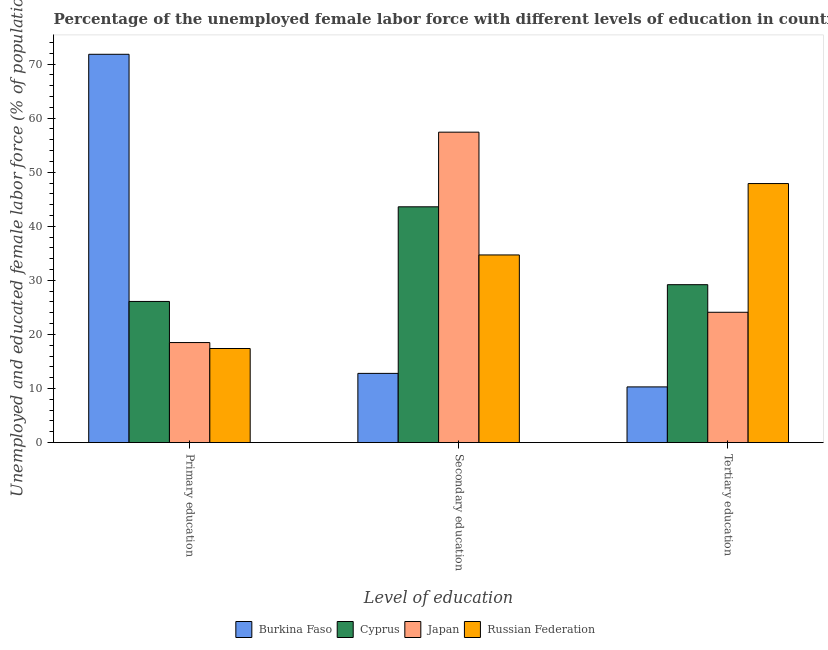What is the label of the 3rd group of bars from the left?
Provide a succinct answer. Tertiary education. What is the percentage of female labor force who received tertiary education in Japan?
Offer a very short reply. 24.1. Across all countries, what is the maximum percentage of female labor force who received secondary education?
Provide a succinct answer. 57.4. Across all countries, what is the minimum percentage of female labor force who received secondary education?
Your answer should be very brief. 12.8. In which country was the percentage of female labor force who received secondary education maximum?
Provide a short and direct response. Japan. In which country was the percentage of female labor force who received primary education minimum?
Give a very brief answer. Russian Federation. What is the total percentage of female labor force who received secondary education in the graph?
Offer a very short reply. 148.5. What is the difference between the percentage of female labor force who received primary education in Japan and that in Cyprus?
Your answer should be compact. -7.6. What is the difference between the percentage of female labor force who received secondary education in Japan and the percentage of female labor force who received primary education in Burkina Faso?
Offer a very short reply. -14.4. What is the average percentage of female labor force who received secondary education per country?
Your response must be concise. 37.13. What is the difference between the percentage of female labor force who received primary education and percentage of female labor force who received tertiary education in Burkina Faso?
Offer a very short reply. 61.5. In how many countries, is the percentage of female labor force who received tertiary education greater than 26 %?
Keep it short and to the point. 2. What is the ratio of the percentage of female labor force who received tertiary education in Burkina Faso to that in Japan?
Offer a terse response. 0.43. Is the percentage of female labor force who received tertiary education in Russian Federation less than that in Cyprus?
Your response must be concise. No. What is the difference between the highest and the second highest percentage of female labor force who received tertiary education?
Make the answer very short. 18.7. What is the difference between the highest and the lowest percentage of female labor force who received tertiary education?
Ensure brevity in your answer.  37.6. What does the 2nd bar from the right in Secondary education represents?
Your response must be concise. Japan. How many bars are there?
Give a very brief answer. 12. Are all the bars in the graph horizontal?
Provide a short and direct response. No. Are the values on the major ticks of Y-axis written in scientific E-notation?
Give a very brief answer. No. Does the graph contain any zero values?
Provide a succinct answer. No. Where does the legend appear in the graph?
Offer a very short reply. Bottom center. What is the title of the graph?
Ensure brevity in your answer.  Percentage of the unemployed female labor force with different levels of education in countries. What is the label or title of the X-axis?
Offer a terse response. Level of education. What is the label or title of the Y-axis?
Your answer should be very brief. Unemployed and educated female labor force (% of population). What is the Unemployed and educated female labor force (% of population) in Burkina Faso in Primary education?
Offer a terse response. 71.8. What is the Unemployed and educated female labor force (% of population) in Cyprus in Primary education?
Ensure brevity in your answer.  26.1. What is the Unemployed and educated female labor force (% of population) in Japan in Primary education?
Offer a terse response. 18.5. What is the Unemployed and educated female labor force (% of population) of Russian Federation in Primary education?
Offer a terse response. 17.4. What is the Unemployed and educated female labor force (% of population) in Burkina Faso in Secondary education?
Provide a short and direct response. 12.8. What is the Unemployed and educated female labor force (% of population) of Cyprus in Secondary education?
Your answer should be compact. 43.6. What is the Unemployed and educated female labor force (% of population) in Japan in Secondary education?
Keep it short and to the point. 57.4. What is the Unemployed and educated female labor force (% of population) of Russian Federation in Secondary education?
Your answer should be compact. 34.7. What is the Unemployed and educated female labor force (% of population) in Burkina Faso in Tertiary education?
Ensure brevity in your answer.  10.3. What is the Unemployed and educated female labor force (% of population) in Cyprus in Tertiary education?
Your response must be concise. 29.2. What is the Unemployed and educated female labor force (% of population) in Japan in Tertiary education?
Offer a very short reply. 24.1. What is the Unemployed and educated female labor force (% of population) in Russian Federation in Tertiary education?
Your answer should be very brief. 47.9. Across all Level of education, what is the maximum Unemployed and educated female labor force (% of population) of Burkina Faso?
Provide a short and direct response. 71.8. Across all Level of education, what is the maximum Unemployed and educated female labor force (% of population) of Cyprus?
Provide a short and direct response. 43.6. Across all Level of education, what is the maximum Unemployed and educated female labor force (% of population) of Japan?
Provide a short and direct response. 57.4. Across all Level of education, what is the maximum Unemployed and educated female labor force (% of population) in Russian Federation?
Ensure brevity in your answer.  47.9. Across all Level of education, what is the minimum Unemployed and educated female labor force (% of population) of Burkina Faso?
Give a very brief answer. 10.3. Across all Level of education, what is the minimum Unemployed and educated female labor force (% of population) in Cyprus?
Your response must be concise. 26.1. Across all Level of education, what is the minimum Unemployed and educated female labor force (% of population) of Japan?
Give a very brief answer. 18.5. Across all Level of education, what is the minimum Unemployed and educated female labor force (% of population) of Russian Federation?
Provide a short and direct response. 17.4. What is the total Unemployed and educated female labor force (% of population) of Burkina Faso in the graph?
Offer a very short reply. 94.9. What is the total Unemployed and educated female labor force (% of population) of Cyprus in the graph?
Offer a terse response. 98.9. What is the total Unemployed and educated female labor force (% of population) in Japan in the graph?
Your answer should be very brief. 100. What is the difference between the Unemployed and educated female labor force (% of population) in Burkina Faso in Primary education and that in Secondary education?
Make the answer very short. 59. What is the difference between the Unemployed and educated female labor force (% of population) in Cyprus in Primary education and that in Secondary education?
Your answer should be compact. -17.5. What is the difference between the Unemployed and educated female labor force (% of population) in Japan in Primary education and that in Secondary education?
Offer a terse response. -38.9. What is the difference between the Unemployed and educated female labor force (% of population) of Russian Federation in Primary education and that in Secondary education?
Give a very brief answer. -17.3. What is the difference between the Unemployed and educated female labor force (% of population) of Burkina Faso in Primary education and that in Tertiary education?
Give a very brief answer. 61.5. What is the difference between the Unemployed and educated female labor force (% of population) in Japan in Primary education and that in Tertiary education?
Offer a very short reply. -5.6. What is the difference between the Unemployed and educated female labor force (% of population) of Russian Federation in Primary education and that in Tertiary education?
Your response must be concise. -30.5. What is the difference between the Unemployed and educated female labor force (% of population) of Burkina Faso in Secondary education and that in Tertiary education?
Provide a short and direct response. 2.5. What is the difference between the Unemployed and educated female labor force (% of population) of Japan in Secondary education and that in Tertiary education?
Ensure brevity in your answer.  33.3. What is the difference between the Unemployed and educated female labor force (% of population) of Burkina Faso in Primary education and the Unemployed and educated female labor force (% of population) of Cyprus in Secondary education?
Your answer should be very brief. 28.2. What is the difference between the Unemployed and educated female labor force (% of population) in Burkina Faso in Primary education and the Unemployed and educated female labor force (% of population) in Japan in Secondary education?
Provide a short and direct response. 14.4. What is the difference between the Unemployed and educated female labor force (% of population) of Burkina Faso in Primary education and the Unemployed and educated female labor force (% of population) of Russian Federation in Secondary education?
Your answer should be compact. 37.1. What is the difference between the Unemployed and educated female labor force (% of population) in Cyprus in Primary education and the Unemployed and educated female labor force (% of population) in Japan in Secondary education?
Make the answer very short. -31.3. What is the difference between the Unemployed and educated female labor force (% of population) in Japan in Primary education and the Unemployed and educated female labor force (% of population) in Russian Federation in Secondary education?
Give a very brief answer. -16.2. What is the difference between the Unemployed and educated female labor force (% of population) of Burkina Faso in Primary education and the Unemployed and educated female labor force (% of population) of Cyprus in Tertiary education?
Make the answer very short. 42.6. What is the difference between the Unemployed and educated female labor force (% of population) of Burkina Faso in Primary education and the Unemployed and educated female labor force (% of population) of Japan in Tertiary education?
Your answer should be compact. 47.7. What is the difference between the Unemployed and educated female labor force (% of population) of Burkina Faso in Primary education and the Unemployed and educated female labor force (% of population) of Russian Federation in Tertiary education?
Ensure brevity in your answer.  23.9. What is the difference between the Unemployed and educated female labor force (% of population) in Cyprus in Primary education and the Unemployed and educated female labor force (% of population) in Russian Federation in Tertiary education?
Provide a short and direct response. -21.8. What is the difference between the Unemployed and educated female labor force (% of population) of Japan in Primary education and the Unemployed and educated female labor force (% of population) of Russian Federation in Tertiary education?
Your response must be concise. -29.4. What is the difference between the Unemployed and educated female labor force (% of population) in Burkina Faso in Secondary education and the Unemployed and educated female labor force (% of population) in Cyprus in Tertiary education?
Your answer should be very brief. -16.4. What is the difference between the Unemployed and educated female labor force (% of population) of Burkina Faso in Secondary education and the Unemployed and educated female labor force (% of population) of Japan in Tertiary education?
Keep it short and to the point. -11.3. What is the difference between the Unemployed and educated female labor force (% of population) of Burkina Faso in Secondary education and the Unemployed and educated female labor force (% of population) of Russian Federation in Tertiary education?
Your answer should be very brief. -35.1. What is the difference between the Unemployed and educated female labor force (% of population) of Cyprus in Secondary education and the Unemployed and educated female labor force (% of population) of Japan in Tertiary education?
Your response must be concise. 19.5. What is the difference between the Unemployed and educated female labor force (% of population) in Cyprus in Secondary education and the Unemployed and educated female labor force (% of population) in Russian Federation in Tertiary education?
Your response must be concise. -4.3. What is the average Unemployed and educated female labor force (% of population) in Burkina Faso per Level of education?
Make the answer very short. 31.63. What is the average Unemployed and educated female labor force (% of population) of Cyprus per Level of education?
Your answer should be very brief. 32.97. What is the average Unemployed and educated female labor force (% of population) of Japan per Level of education?
Give a very brief answer. 33.33. What is the average Unemployed and educated female labor force (% of population) in Russian Federation per Level of education?
Ensure brevity in your answer.  33.33. What is the difference between the Unemployed and educated female labor force (% of population) of Burkina Faso and Unemployed and educated female labor force (% of population) of Cyprus in Primary education?
Provide a short and direct response. 45.7. What is the difference between the Unemployed and educated female labor force (% of population) of Burkina Faso and Unemployed and educated female labor force (% of population) of Japan in Primary education?
Give a very brief answer. 53.3. What is the difference between the Unemployed and educated female labor force (% of population) of Burkina Faso and Unemployed and educated female labor force (% of population) of Russian Federation in Primary education?
Offer a very short reply. 54.4. What is the difference between the Unemployed and educated female labor force (% of population) in Cyprus and Unemployed and educated female labor force (% of population) in Japan in Primary education?
Make the answer very short. 7.6. What is the difference between the Unemployed and educated female labor force (% of population) of Cyprus and Unemployed and educated female labor force (% of population) of Russian Federation in Primary education?
Provide a short and direct response. 8.7. What is the difference between the Unemployed and educated female labor force (% of population) in Japan and Unemployed and educated female labor force (% of population) in Russian Federation in Primary education?
Offer a very short reply. 1.1. What is the difference between the Unemployed and educated female labor force (% of population) of Burkina Faso and Unemployed and educated female labor force (% of population) of Cyprus in Secondary education?
Offer a very short reply. -30.8. What is the difference between the Unemployed and educated female labor force (% of population) in Burkina Faso and Unemployed and educated female labor force (% of population) in Japan in Secondary education?
Give a very brief answer. -44.6. What is the difference between the Unemployed and educated female labor force (% of population) in Burkina Faso and Unemployed and educated female labor force (% of population) in Russian Federation in Secondary education?
Make the answer very short. -21.9. What is the difference between the Unemployed and educated female labor force (% of population) in Japan and Unemployed and educated female labor force (% of population) in Russian Federation in Secondary education?
Keep it short and to the point. 22.7. What is the difference between the Unemployed and educated female labor force (% of population) in Burkina Faso and Unemployed and educated female labor force (% of population) in Cyprus in Tertiary education?
Keep it short and to the point. -18.9. What is the difference between the Unemployed and educated female labor force (% of population) in Burkina Faso and Unemployed and educated female labor force (% of population) in Russian Federation in Tertiary education?
Ensure brevity in your answer.  -37.6. What is the difference between the Unemployed and educated female labor force (% of population) in Cyprus and Unemployed and educated female labor force (% of population) in Japan in Tertiary education?
Keep it short and to the point. 5.1. What is the difference between the Unemployed and educated female labor force (% of population) of Cyprus and Unemployed and educated female labor force (% of population) of Russian Federation in Tertiary education?
Your answer should be compact. -18.7. What is the difference between the Unemployed and educated female labor force (% of population) in Japan and Unemployed and educated female labor force (% of population) in Russian Federation in Tertiary education?
Your answer should be very brief. -23.8. What is the ratio of the Unemployed and educated female labor force (% of population) in Burkina Faso in Primary education to that in Secondary education?
Keep it short and to the point. 5.61. What is the ratio of the Unemployed and educated female labor force (% of population) of Cyprus in Primary education to that in Secondary education?
Your answer should be compact. 0.6. What is the ratio of the Unemployed and educated female labor force (% of population) in Japan in Primary education to that in Secondary education?
Ensure brevity in your answer.  0.32. What is the ratio of the Unemployed and educated female labor force (% of population) of Russian Federation in Primary education to that in Secondary education?
Your answer should be very brief. 0.5. What is the ratio of the Unemployed and educated female labor force (% of population) of Burkina Faso in Primary education to that in Tertiary education?
Your response must be concise. 6.97. What is the ratio of the Unemployed and educated female labor force (% of population) in Cyprus in Primary education to that in Tertiary education?
Your answer should be very brief. 0.89. What is the ratio of the Unemployed and educated female labor force (% of population) in Japan in Primary education to that in Tertiary education?
Your answer should be compact. 0.77. What is the ratio of the Unemployed and educated female labor force (% of population) of Russian Federation in Primary education to that in Tertiary education?
Provide a succinct answer. 0.36. What is the ratio of the Unemployed and educated female labor force (% of population) of Burkina Faso in Secondary education to that in Tertiary education?
Give a very brief answer. 1.24. What is the ratio of the Unemployed and educated female labor force (% of population) in Cyprus in Secondary education to that in Tertiary education?
Give a very brief answer. 1.49. What is the ratio of the Unemployed and educated female labor force (% of population) of Japan in Secondary education to that in Tertiary education?
Keep it short and to the point. 2.38. What is the ratio of the Unemployed and educated female labor force (% of population) of Russian Federation in Secondary education to that in Tertiary education?
Ensure brevity in your answer.  0.72. What is the difference between the highest and the second highest Unemployed and educated female labor force (% of population) of Burkina Faso?
Offer a terse response. 59. What is the difference between the highest and the second highest Unemployed and educated female labor force (% of population) of Japan?
Give a very brief answer. 33.3. What is the difference between the highest and the second highest Unemployed and educated female labor force (% of population) in Russian Federation?
Provide a short and direct response. 13.2. What is the difference between the highest and the lowest Unemployed and educated female labor force (% of population) in Burkina Faso?
Keep it short and to the point. 61.5. What is the difference between the highest and the lowest Unemployed and educated female labor force (% of population) in Japan?
Make the answer very short. 38.9. What is the difference between the highest and the lowest Unemployed and educated female labor force (% of population) of Russian Federation?
Offer a terse response. 30.5. 